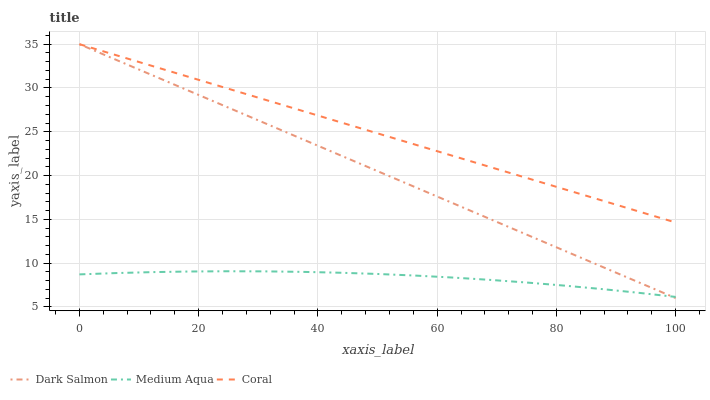Does Medium Aqua have the minimum area under the curve?
Answer yes or no. Yes. Does Coral have the maximum area under the curve?
Answer yes or no. Yes. Does Dark Salmon have the minimum area under the curve?
Answer yes or no. No. Does Dark Salmon have the maximum area under the curve?
Answer yes or no. No. Is Dark Salmon the smoothest?
Answer yes or no. Yes. Is Medium Aqua the roughest?
Answer yes or no. Yes. Is Medium Aqua the smoothest?
Answer yes or no. No. Is Dark Salmon the roughest?
Answer yes or no. No. Does Dark Salmon have the lowest value?
Answer yes or no. Yes. Does Medium Aqua have the lowest value?
Answer yes or no. No. Does Dark Salmon have the highest value?
Answer yes or no. Yes. Does Medium Aqua have the highest value?
Answer yes or no. No. Is Medium Aqua less than Coral?
Answer yes or no. Yes. Is Coral greater than Medium Aqua?
Answer yes or no. Yes. Does Dark Salmon intersect Coral?
Answer yes or no. Yes. Is Dark Salmon less than Coral?
Answer yes or no. No. Is Dark Salmon greater than Coral?
Answer yes or no. No. Does Medium Aqua intersect Coral?
Answer yes or no. No. 